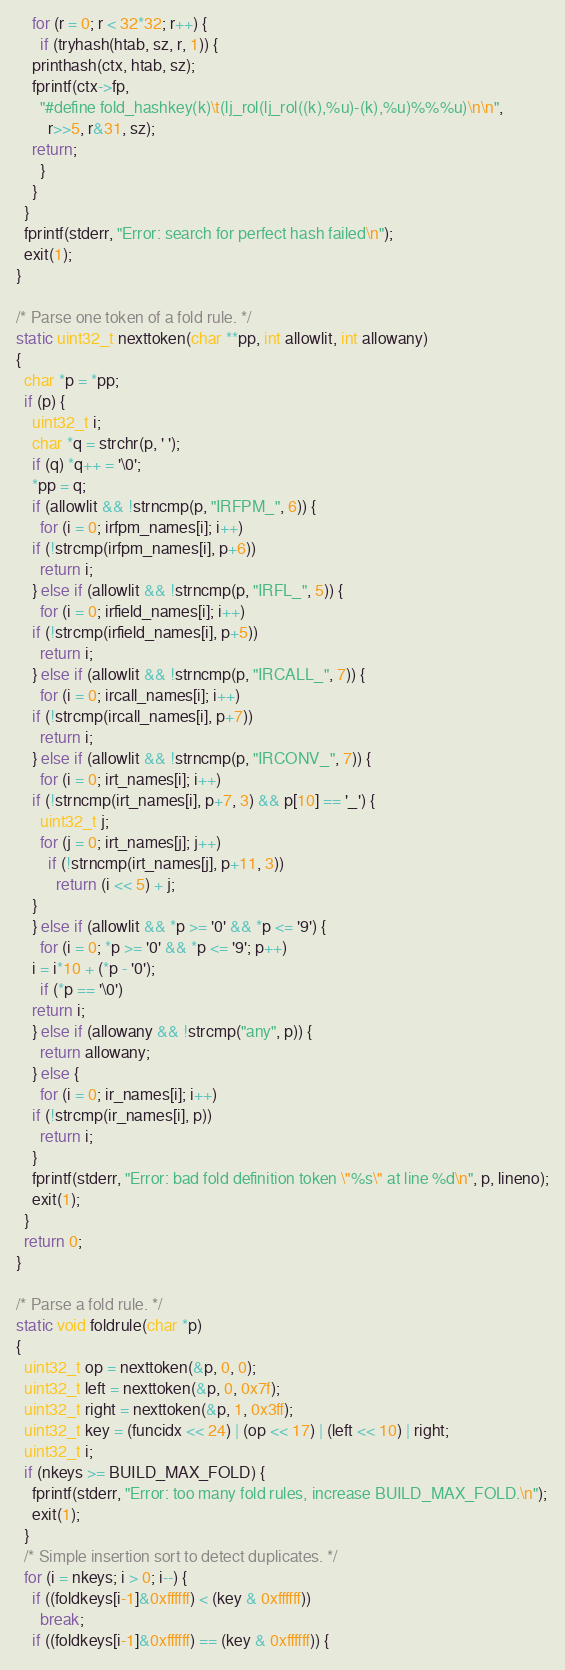<code> <loc_0><loc_0><loc_500><loc_500><_C_>    for (r = 0; r < 32*32; r++) {
      if (tryhash(htab, sz, r, 1)) {
	printhash(ctx, htab, sz);
	fprintf(ctx->fp,
	  "#define fold_hashkey(k)\t(lj_rol(lj_rol((k),%u)-(k),%u)%%%u)\n\n",
		r>>5, r&31, sz);
	return;
      }
    }
  }
  fprintf(stderr, "Error: search for perfect hash failed\n");
  exit(1);
}

/* Parse one token of a fold rule. */
static uint32_t nexttoken(char **pp, int allowlit, int allowany)
{
  char *p = *pp;
  if (p) {
    uint32_t i;
    char *q = strchr(p, ' ');
    if (q) *q++ = '\0';
    *pp = q;
    if (allowlit && !strncmp(p, "IRFPM_", 6)) {
      for (i = 0; irfpm_names[i]; i++)
	if (!strcmp(irfpm_names[i], p+6))
	  return i;
    } else if (allowlit && !strncmp(p, "IRFL_", 5)) {
      for (i = 0; irfield_names[i]; i++)
	if (!strcmp(irfield_names[i], p+5))
	  return i;
    } else if (allowlit && !strncmp(p, "IRCALL_", 7)) {
      for (i = 0; ircall_names[i]; i++)
	if (!strcmp(ircall_names[i], p+7))
	  return i;
    } else if (allowlit && !strncmp(p, "IRCONV_", 7)) {
      for (i = 0; irt_names[i]; i++)
	if (!strncmp(irt_names[i], p+7, 3) && p[10] == '_') {
	  uint32_t j;
	  for (j = 0; irt_names[j]; j++)
	    if (!strncmp(irt_names[j], p+11, 3))
	      return (i << 5) + j;
	}
    } else if (allowlit && *p >= '0' && *p <= '9') {
      for (i = 0; *p >= '0' && *p <= '9'; p++)
	i = i*10 + (*p - '0');
      if (*p == '\0')
	return i;
    } else if (allowany && !strcmp("any", p)) {
      return allowany;
    } else {
      for (i = 0; ir_names[i]; i++)
	if (!strcmp(ir_names[i], p))
	  return i;
    }
    fprintf(stderr, "Error: bad fold definition token \"%s\" at line %d\n", p, lineno);
    exit(1);
  }
  return 0;
}

/* Parse a fold rule. */
static void foldrule(char *p)
{
  uint32_t op = nexttoken(&p, 0, 0);
  uint32_t left = nexttoken(&p, 0, 0x7f);
  uint32_t right = nexttoken(&p, 1, 0x3ff);
  uint32_t key = (funcidx << 24) | (op << 17) | (left << 10) | right;
  uint32_t i;
  if (nkeys >= BUILD_MAX_FOLD) {
    fprintf(stderr, "Error: too many fold rules, increase BUILD_MAX_FOLD.\n");
    exit(1);
  }
  /* Simple insertion sort to detect duplicates. */
  for (i = nkeys; i > 0; i--) {
    if ((foldkeys[i-1]&0xffffff) < (key & 0xffffff))
      break;
    if ((foldkeys[i-1]&0xffffff) == (key & 0xffffff)) {</code> 